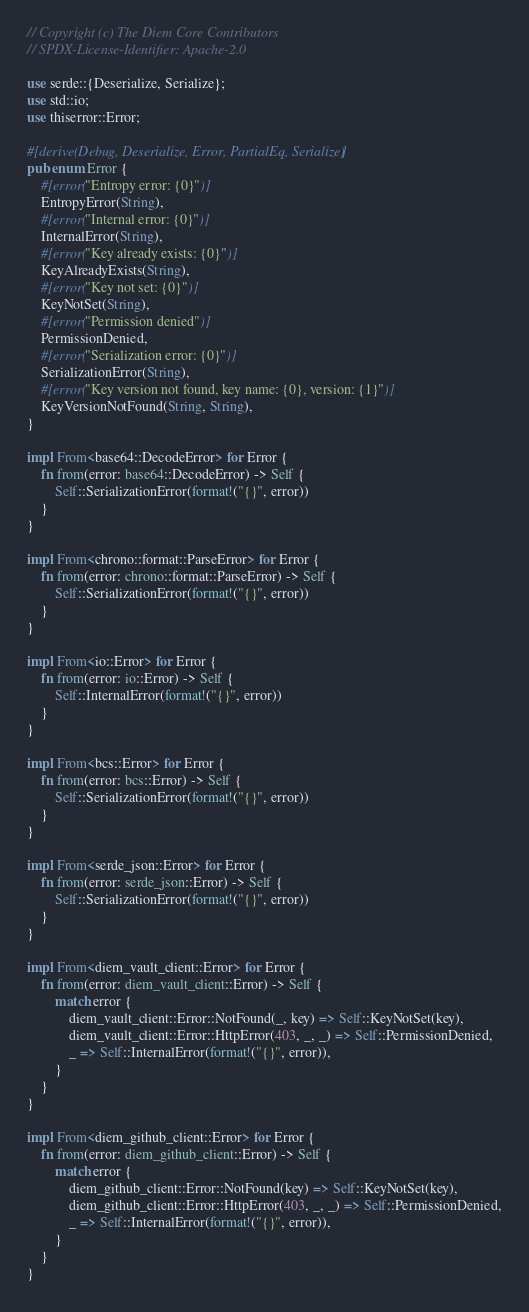Convert code to text. <code><loc_0><loc_0><loc_500><loc_500><_Rust_>// Copyright (c) The Diem Core Contributors
// SPDX-License-Identifier: Apache-2.0

use serde::{Deserialize, Serialize};
use std::io;
use thiserror::Error;

#[derive(Debug, Deserialize, Error, PartialEq, Serialize)]
pub enum Error {
    #[error("Entropy error: {0}")]
    EntropyError(String),
    #[error("Internal error: {0}")]
    InternalError(String),
    #[error("Key already exists: {0}")]
    KeyAlreadyExists(String),
    #[error("Key not set: {0}")]
    KeyNotSet(String),
    #[error("Permission denied")]
    PermissionDenied,
    #[error("Serialization error: {0}")]
    SerializationError(String),
    #[error("Key version not found, key name: {0}, version: {1}")]
    KeyVersionNotFound(String, String),
}

impl From<base64::DecodeError> for Error {
    fn from(error: base64::DecodeError) -> Self {
        Self::SerializationError(format!("{}", error))
    }
}

impl From<chrono::format::ParseError> for Error {
    fn from(error: chrono::format::ParseError) -> Self {
        Self::SerializationError(format!("{}", error))
    }
}

impl From<io::Error> for Error {
    fn from(error: io::Error) -> Self {
        Self::InternalError(format!("{}", error))
    }
}

impl From<bcs::Error> for Error {
    fn from(error: bcs::Error) -> Self {
        Self::SerializationError(format!("{}", error))
    }
}

impl From<serde_json::Error> for Error {
    fn from(error: serde_json::Error) -> Self {
        Self::SerializationError(format!("{}", error))
    }
}

impl From<diem_vault_client::Error> for Error {
    fn from(error: diem_vault_client::Error) -> Self {
        match error {
            diem_vault_client::Error::NotFound(_, key) => Self::KeyNotSet(key),
            diem_vault_client::Error::HttpError(403, _, _) => Self::PermissionDenied,
            _ => Self::InternalError(format!("{}", error)),
        }
    }
}

impl From<diem_github_client::Error> for Error {
    fn from(error: diem_github_client::Error) -> Self {
        match error {
            diem_github_client::Error::NotFound(key) => Self::KeyNotSet(key),
            diem_github_client::Error::HttpError(403, _, _) => Self::PermissionDenied,
            _ => Self::InternalError(format!("{}", error)),
        }
    }
}
</code> 